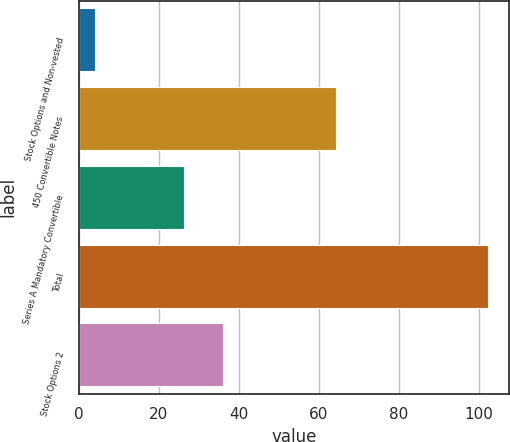<chart> <loc_0><loc_0><loc_500><loc_500><bar_chart><fcel>Stock Options and Non-vested<fcel>450 Convertible Notes<fcel>Series A Mandatory Convertible<fcel>Total<fcel>Stock Options 2<nl><fcel>4<fcel>64.4<fcel>26.3<fcel>102.4<fcel>36.14<nl></chart> 